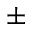<formula> <loc_0><loc_0><loc_500><loc_500>\pm</formula> 